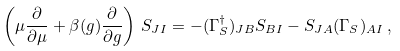<formula> <loc_0><loc_0><loc_500><loc_500>\left ( \mu { \frac { \partial } { \partial \mu } } + \beta ( g ) { \frac { \partial } { \partial g } } \right ) \, S _ { J I } = - ( \Gamma _ { S } ^ { \dagger } ) _ { J B } S _ { B I } - S _ { J A } ( \Gamma _ { S } ) _ { A I } \, ,</formula> 